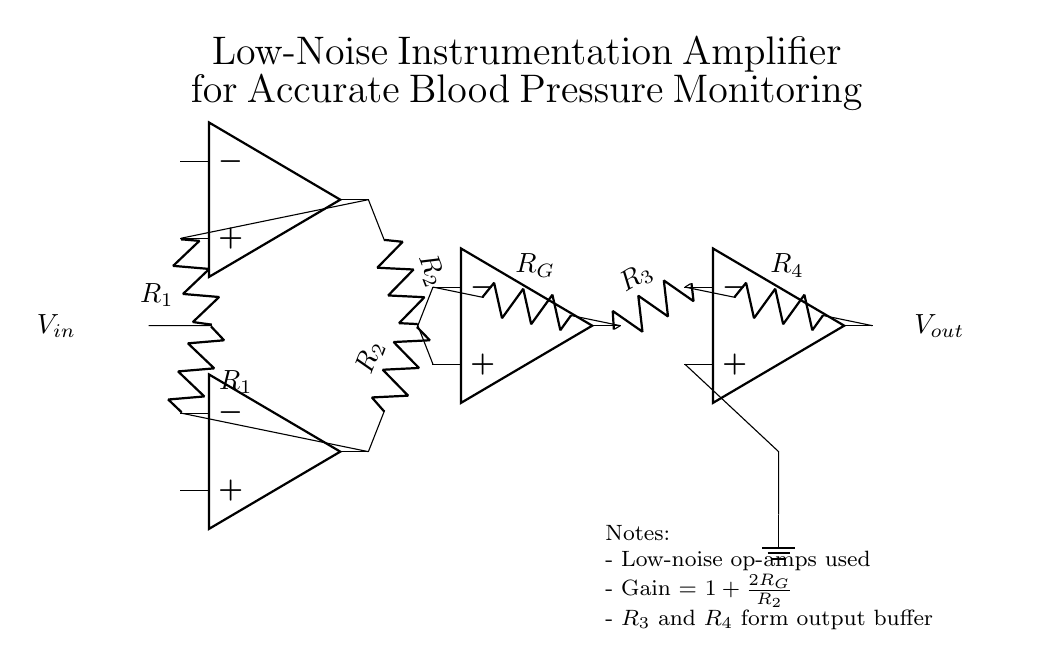What is the type of amplifier shown? The amplifier is an instrumentation amplifier, which is designed for precise low-noise signal amplification, commonly used in medical applications. The circuit layout indicates multiple op-amps configured for this purpose.
Answer: instrumentation amplifier How many operational amplifiers are used in the circuit? The circuit diagram includes a total of four operational amplifiers, as indicated by the four op-amp symbols present.
Answer: four What does \( V_{in} \) represent in this circuit? \( V_{in} \) represents the input voltage signal that is being monitored, which in this case relates to blood pressure measurements. It is marked on the left side of the circuit.
Answer: input voltage What is the formula for gain in this amplifier? The formula for gain is \( 1 + \frac{2R_G}{R_2} \). This shows how the resistor values influence the gain of the amplifier.
Answer: 1 + 2R_G/R_2 How do \( R_3 \) and \( R_4 \) function in the circuit? \( R_3 \) and \( R_4 \) form an output buffer which helps to isolate the load from the amplifier's gain stage, ensuring stability and reducing loading effects on the previous stage.
Answer: output buffer What is the intended use of the low-noise instrumentation amplifier in this context? The intended use is for accurate blood pressure monitoring, as indicated by the title of the circuit diagram and the need for low noise in medical signal applications.
Answer: accurate blood pressure monitoring Why is it important to use low-noise op-amps in this circuit? It is important to use low-noise op-amps to minimize signal distortion and maintain the integrity of small input signals, which is crucial for accurate measurements in medical applications like blood pressure monitoring.
Answer: minimize noise 